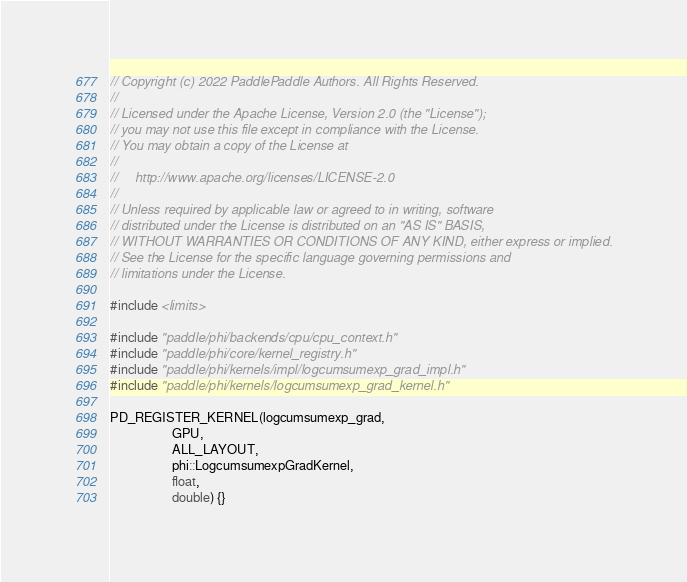Convert code to text. <code><loc_0><loc_0><loc_500><loc_500><_Cuda_>// Copyright (c) 2022 PaddlePaddle Authors. All Rights Reserved.
//
// Licensed under the Apache License, Version 2.0 (the "License");
// you may not use this file except in compliance with the License.
// You may obtain a copy of the License at
//
//     http://www.apache.org/licenses/LICENSE-2.0
//
// Unless required by applicable law or agreed to in writing, software
// distributed under the License is distributed on an "AS IS" BASIS,
// WITHOUT WARRANTIES OR CONDITIONS OF ANY KIND, either express or implied.
// See the License for the specific language governing permissions and
// limitations under the License.

#include <limits>

#include "paddle/phi/backends/cpu/cpu_context.h"
#include "paddle/phi/core/kernel_registry.h"
#include "paddle/phi/kernels/impl/logcumsumexp_grad_impl.h"
#include "paddle/phi/kernels/logcumsumexp_grad_kernel.h"

PD_REGISTER_KERNEL(logcumsumexp_grad,
                   GPU,
                   ALL_LAYOUT,
                   phi::LogcumsumexpGradKernel,
                   float,
                   double) {}
</code> 